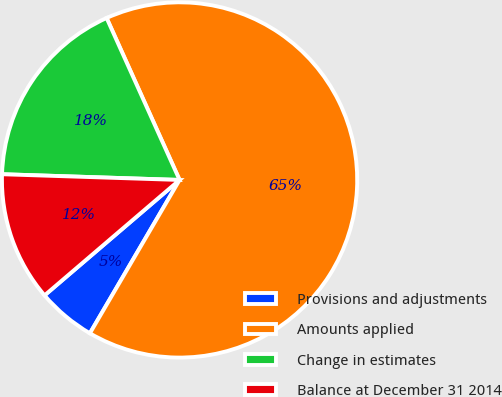<chart> <loc_0><loc_0><loc_500><loc_500><pie_chart><fcel>Provisions and adjustments<fcel>Amounts applied<fcel>Change in estimates<fcel>Balance at December 31 2014<nl><fcel>5.32%<fcel>65.16%<fcel>17.75%<fcel>11.77%<nl></chart> 